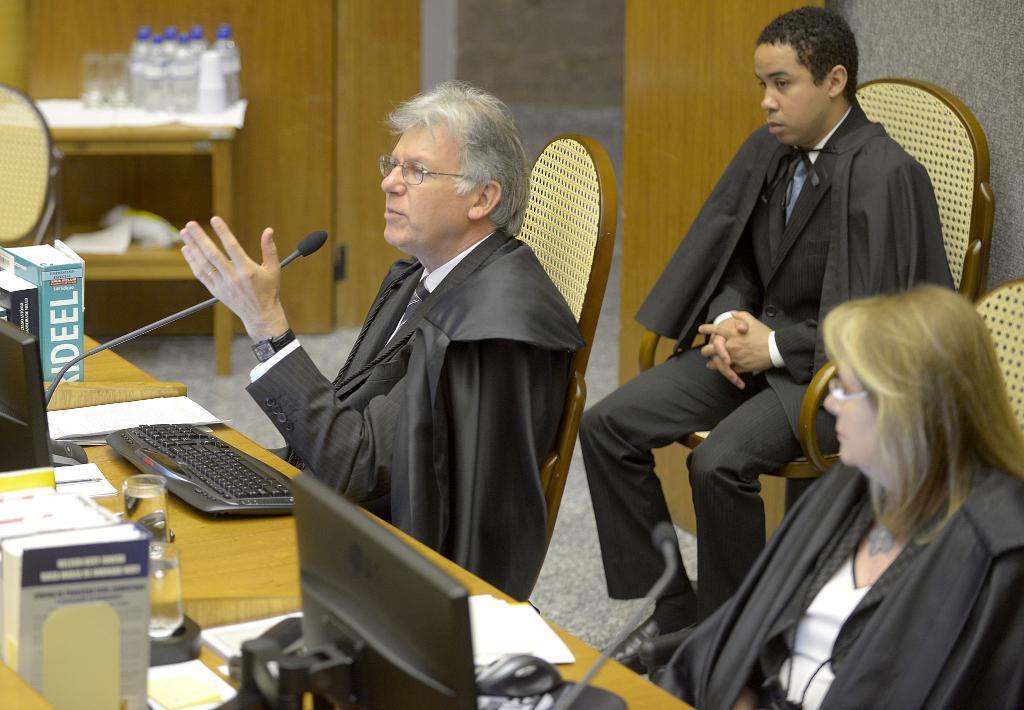How would you summarize this image in a sentence or two? In this images we can see few persons are sitting on the chairs and on the table we can see monitors, keyboard, mouse, glasses, papers, books and micro phones. In the background there are water bottles, glasses on the table, chair and door. 